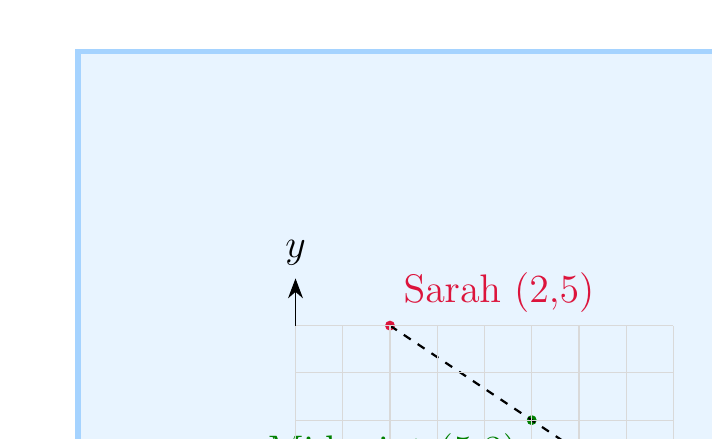Solve this math problem. To find the midpoint of a line segment, we use the midpoint formula:

$$ \text{Midpoint} = \left(\frac{x_1 + x_2}{2}, \frac{y_1 + y_2}{2}\right) $$

Where $(x_1, y_1)$ and $(x_2, y_2)$ are the coordinates of the two endpoints.

Given:
- Sarah's position: $(x_1, y_1) = (2, 5)$
- Emma's position: $(x_2, y_2) = (8, 1)$

Step 1: Calculate the x-coordinate of the midpoint:
$$ x = \frac{x_1 + x_2}{2} = \frac{2 + 8}{2} = \frac{10}{2} = 5 $$

Step 2: Calculate the y-coordinate of the midpoint:
$$ y = \frac{y_1 + y_2}{2} = \frac{5 + 1}{2} = \frac{6}{2} = 3 $$

Therefore, the midpoint coordinates are (5, 3).
Answer: (5, 3) 